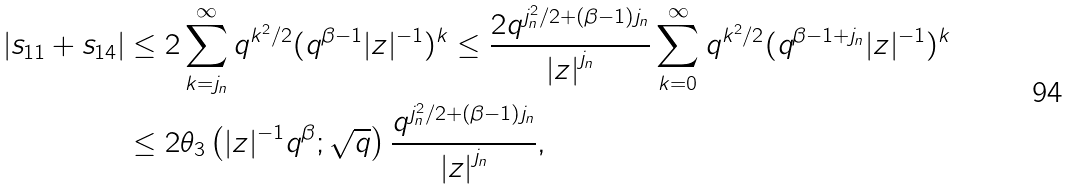<formula> <loc_0><loc_0><loc_500><loc_500>| s _ { 1 1 } + s _ { 1 4 } | & \leq 2 \sum _ { k = j _ { n } } ^ { \infty } q ^ { k ^ { 2 } / 2 } ( q ^ { \beta - 1 } | z | ^ { - 1 } ) ^ { k } \leq \frac { 2 q ^ { j _ { n } ^ { 2 } / 2 + ( \beta - 1 ) j _ { n } } } { \left | z \right | ^ { j _ { n } } } \sum _ { k = 0 } ^ { \infty } q ^ { k ^ { 2 } / 2 } ( q ^ { \beta - 1 + j _ { n } } | z | ^ { - 1 } ) ^ { k } \\ & \leq 2 \theta _ { 3 } \left ( | z | ^ { - 1 } q ^ { \beta } ; \sqrt { q } \right ) \frac { q ^ { j _ { n } ^ { 2 } / 2 + ( \beta - 1 ) j _ { n } } } { \left | z \right | ^ { j _ { n } } } ,</formula> 